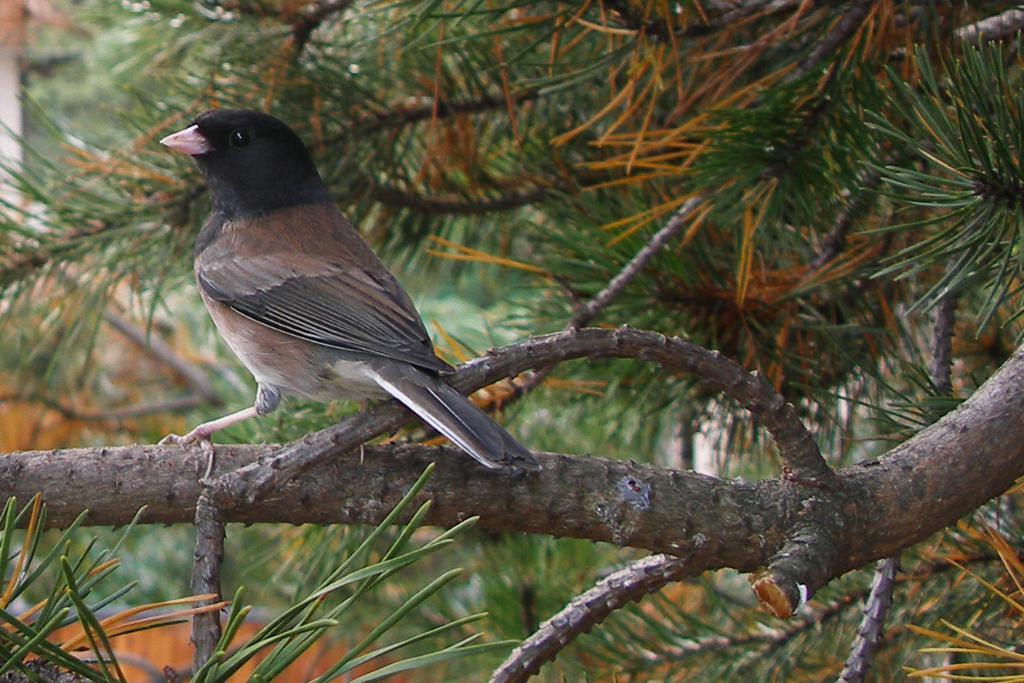Please provide a concise description of this image. In this image in the center there is one bird which is on a tree, in the background there is a house and trees. 